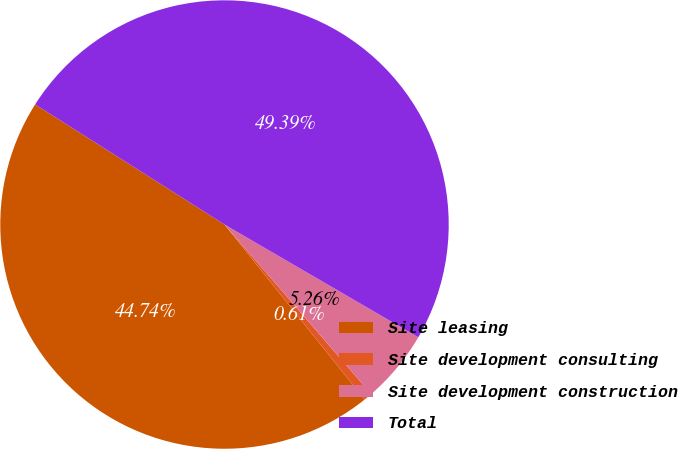<chart> <loc_0><loc_0><loc_500><loc_500><pie_chart><fcel>Site leasing<fcel>Site development consulting<fcel>Site development construction<fcel>Total<nl><fcel>44.74%<fcel>0.61%<fcel>5.26%<fcel>49.39%<nl></chart> 